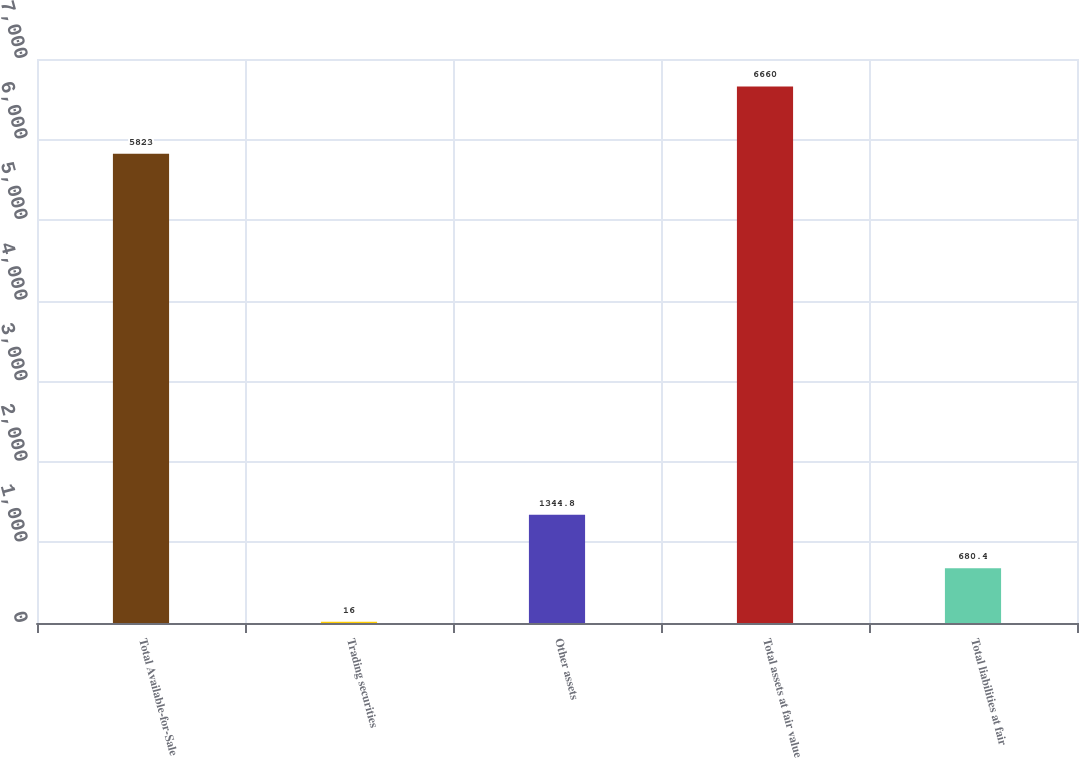Convert chart. <chart><loc_0><loc_0><loc_500><loc_500><bar_chart><fcel>Total Available-for-Sale<fcel>Trading securities<fcel>Other assets<fcel>Total assets at fair value<fcel>Total liabilities at fair<nl><fcel>5823<fcel>16<fcel>1344.8<fcel>6660<fcel>680.4<nl></chart> 